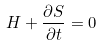<formula> <loc_0><loc_0><loc_500><loc_500>H + \frac { \partial S } { \partial t } = 0</formula> 